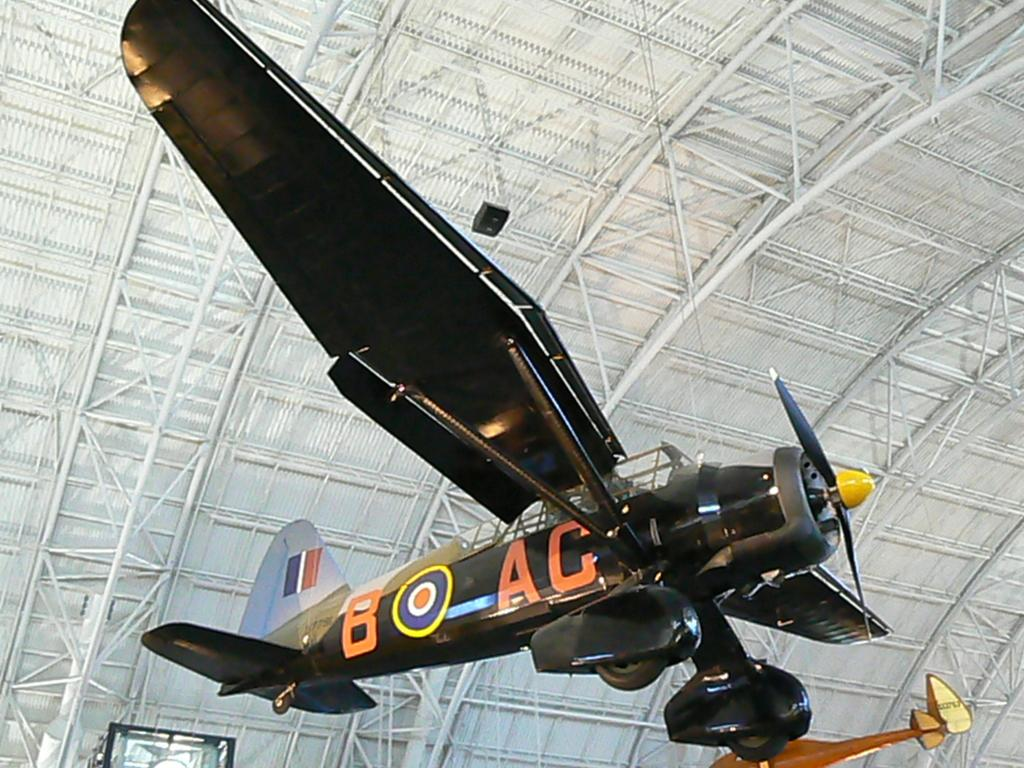<image>
Present a compact description of the photo's key features. A vintage plane, with the identification B target AC hangs overhead. 